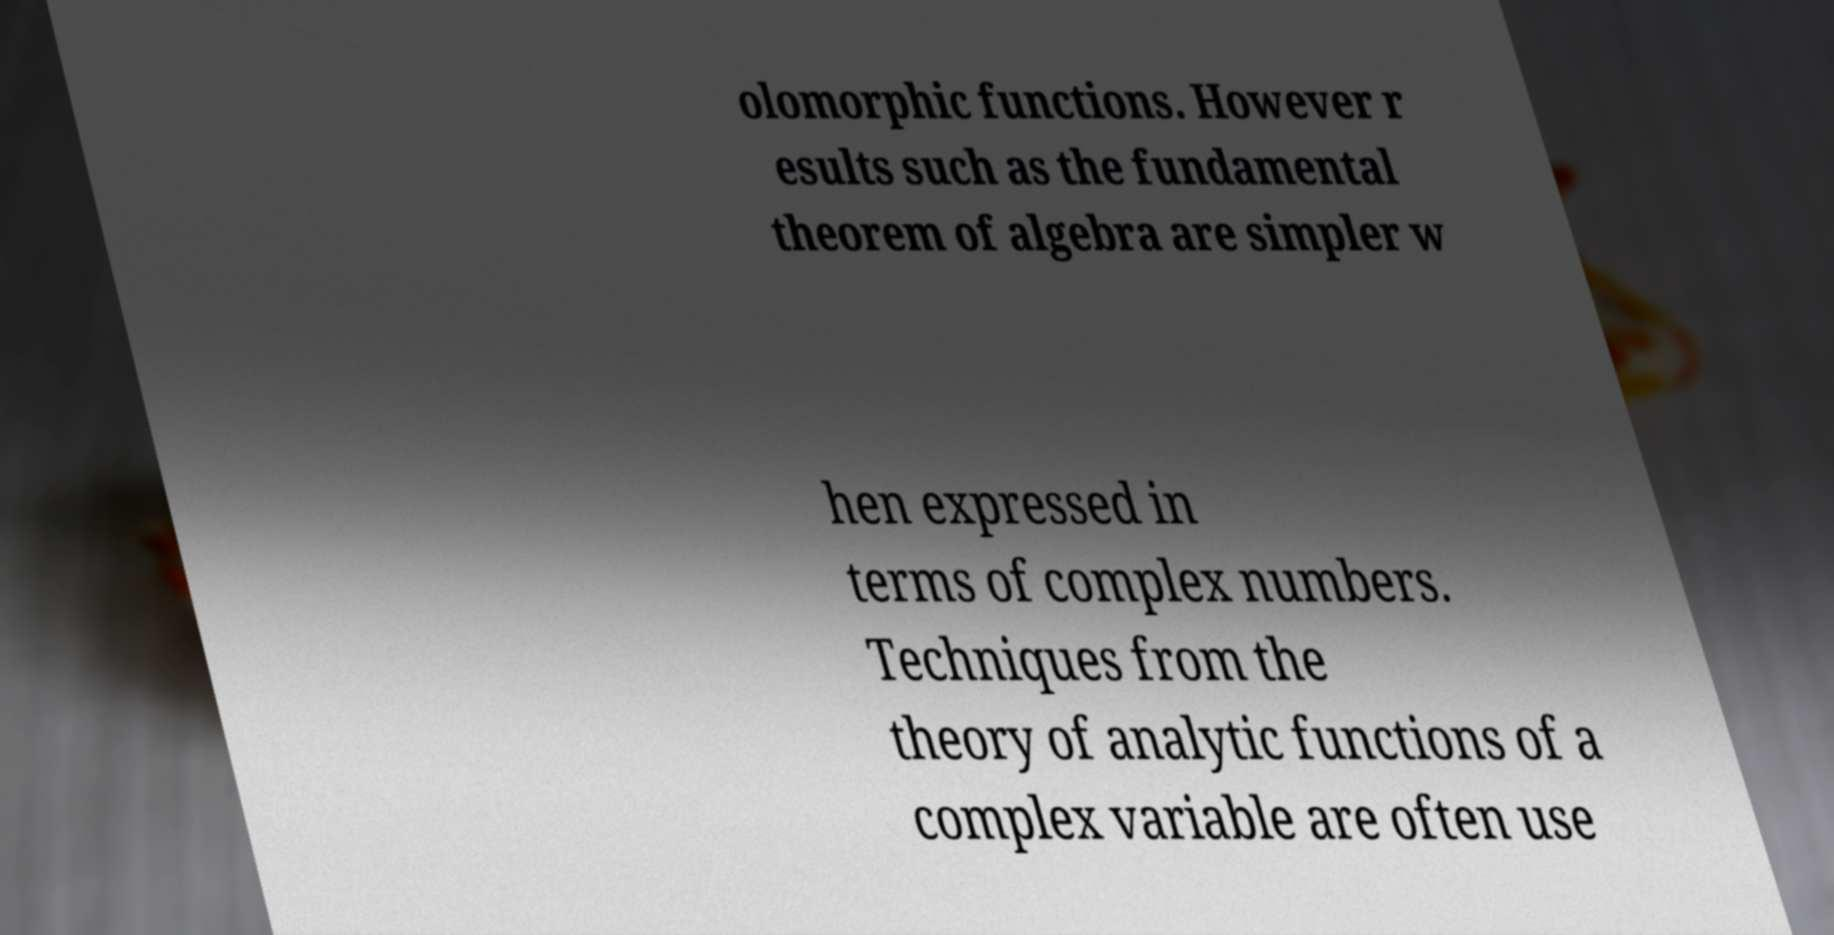Can you read and provide the text displayed in the image?This photo seems to have some interesting text. Can you extract and type it out for me? olomorphic functions. However r esults such as the fundamental theorem of algebra are simpler w hen expressed in terms of complex numbers. Techniques from the theory of analytic functions of a complex variable are often use 